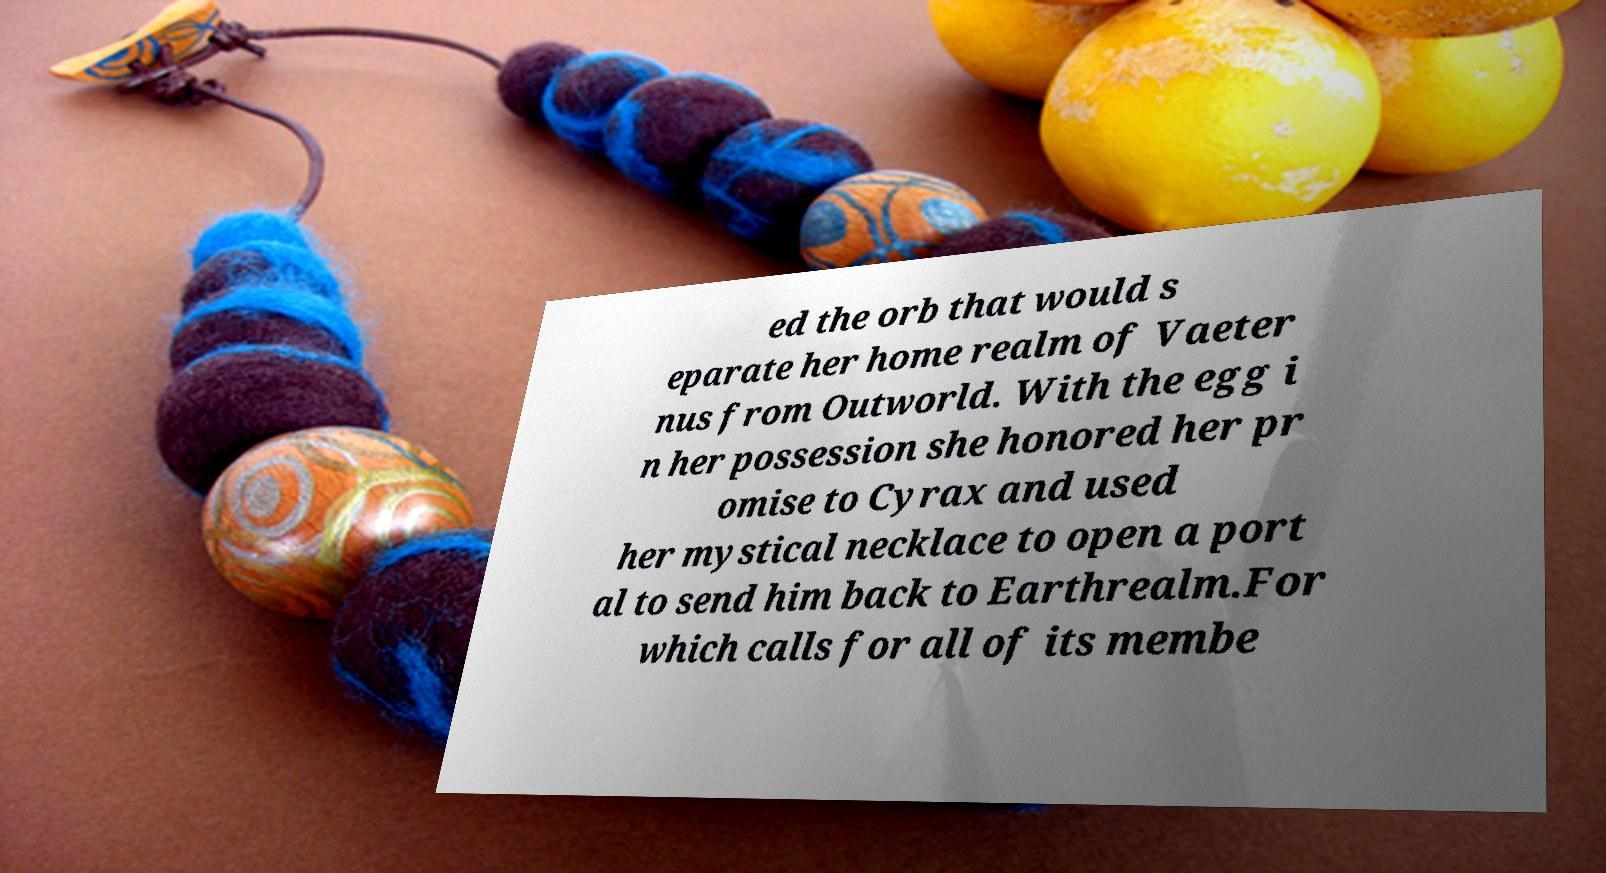Can you accurately transcribe the text from the provided image for me? ed the orb that would s eparate her home realm of Vaeter nus from Outworld. With the egg i n her possession she honored her pr omise to Cyrax and used her mystical necklace to open a port al to send him back to Earthrealm.For which calls for all of its membe 